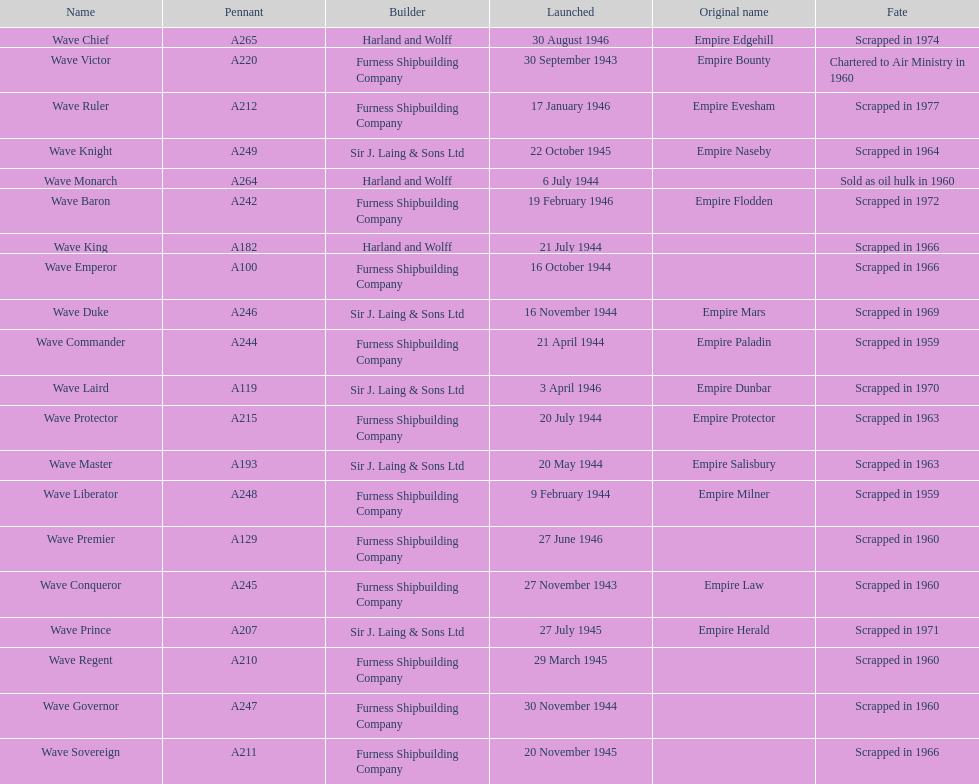Which other ship was launched in the same year as the wave victor? Wave Conqueror. 